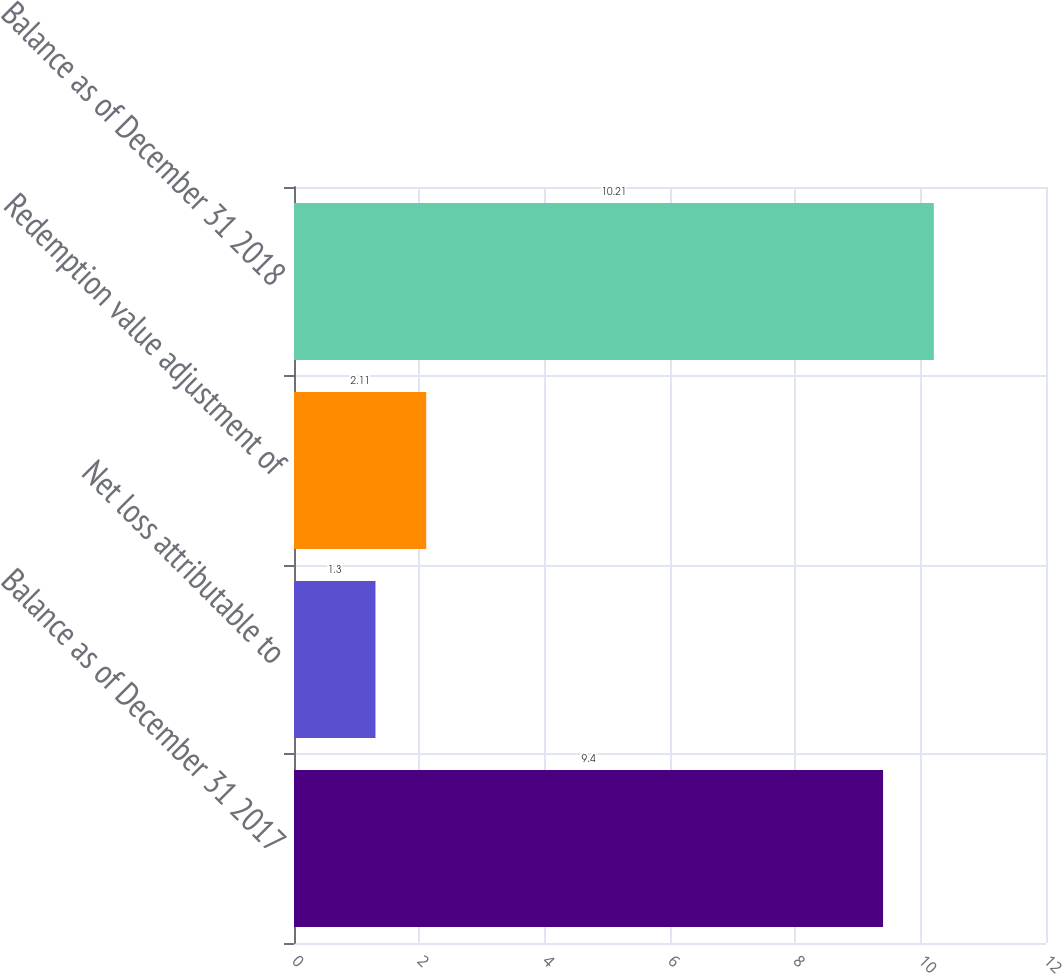Convert chart. <chart><loc_0><loc_0><loc_500><loc_500><bar_chart><fcel>Balance as of December 31 2017<fcel>Net loss attributable to<fcel>Redemption value adjustment of<fcel>Balance as of December 31 2018<nl><fcel>9.4<fcel>1.3<fcel>2.11<fcel>10.21<nl></chart> 